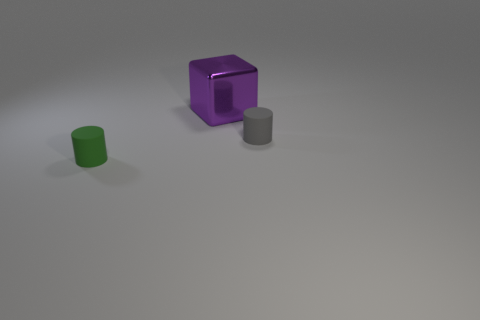What number of other things are there of the same size as the purple shiny thing?
Offer a terse response. 0. Are the tiny cylinder that is right of the large purple metal object and the small cylinder to the left of the tiny gray rubber object made of the same material?
Your answer should be very brief. Yes. What color is the other object that is the same size as the gray rubber thing?
Your answer should be compact. Green. What size is the metal block behind the cylinder on the left side of the small rubber object right of the green rubber cylinder?
Give a very brief answer. Large. What color is the object that is both left of the tiny gray cylinder and in front of the big block?
Give a very brief answer. Green. There is a matte object that is to the right of the metal cube; what is its size?
Give a very brief answer. Small. What number of gray things are made of the same material as the green thing?
Make the answer very short. 1. There is a small thing that is on the right side of the big purple thing; is it the same shape as the tiny green matte thing?
Keep it short and to the point. Yes. There is another tiny cylinder that is the same material as the gray cylinder; what is its color?
Give a very brief answer. Green. There is a purple cube behind the cylinder left of the gray rubber cylinder; are there any green rubber objects behind it?
Your response must be concise. No. 